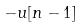Convert formula to latex. <formula><loc_0><loc_0><loc_500><loc_500>- u [ n - 1 ]</formula> 